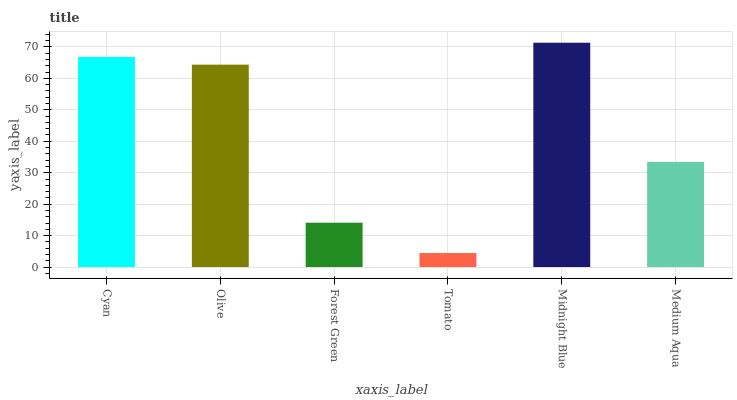Is Tomato the minimum?
Answer yes or no. Yes. Is Midnight Blue the maximum?
Answer yes or no. Yes. Is Olive the minimum?
Answer yes or no. No. Is Olive the maximum?
Answer yes or no. No. Is Cyan greater than Olive?
Answer yes or no. Yes. Is Olive less than Cyan?
Answer yes or no. Yes. Is Olive greater than Cyan?
Answer yes or no. No. Is Cyan less than Olive?
Answer yes or no. No. Is Olive the high median?
Answer yes or no. Yes. Is Medium Aqua the low median?
Answer yes or no. Yes. Is Tomato the high median?
Answer yes or no. No. Is Cyan the low median?
Answer yes or no. No. 